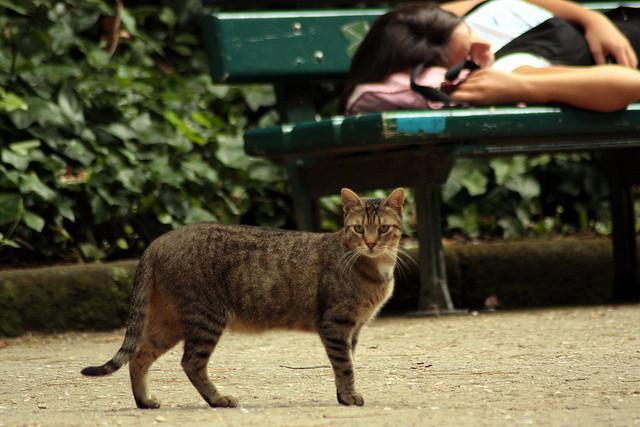How many benches can be seen?
Give a very brief answer. 1. How many motorcycles are in this scene?
Give a very brief answer. 0. 